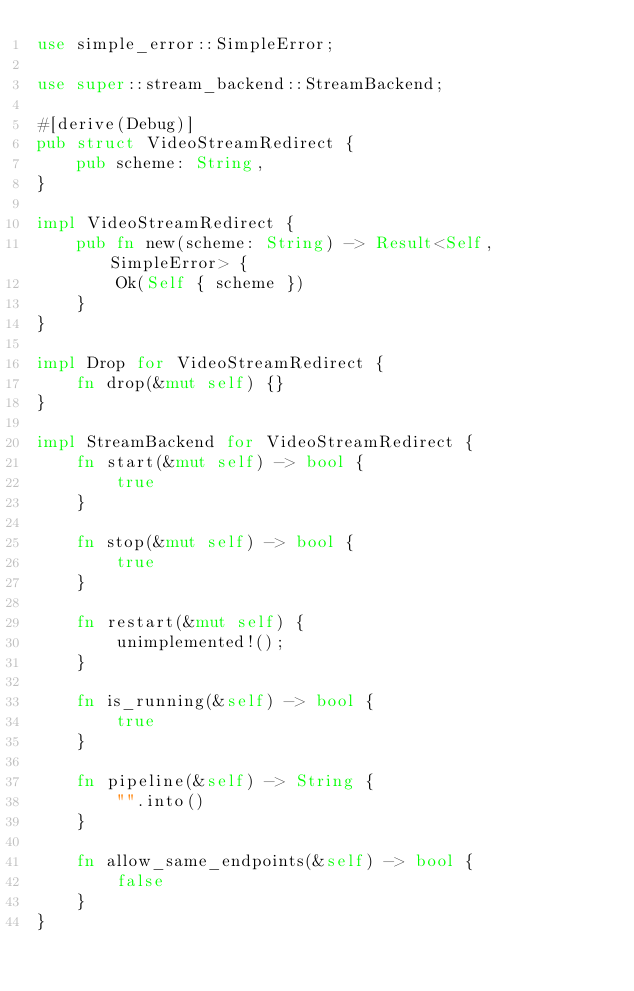<code> <loc_0><loc_0><loc_500><loc_500><_Rust_>use simple_error::SimpleError;

use super::stream_backend::StreamBackend;

#[derive(Debug)]
pub struct VideoStreamRedirect {
    pub scheme: String,
}

impl VideoStreamRedirect {
    pub fn new(scheme: String) -> Result<Self, SimpleError> {
        Ok(Self { scheme })
    }
}

impl Drop for VideoStreamRedirect {
    fn drop(&mut self) {}
}

impl StreamBackend for VideoStreamRedirect {
    fn start(&mut self) -> bool {
        true
    }

    fn stop(&mut self) -> bool {
        true
    }

    fn restart(&mut self) {
        unimplemented!();
    }

    fn is_running(&self) -> bool {
        true
    }

    fn pipeline(&self) -> String {
        "".into()
    }

    fn allow_same_endpoints(&self) -> bool {
        false
    }
}
</code> 